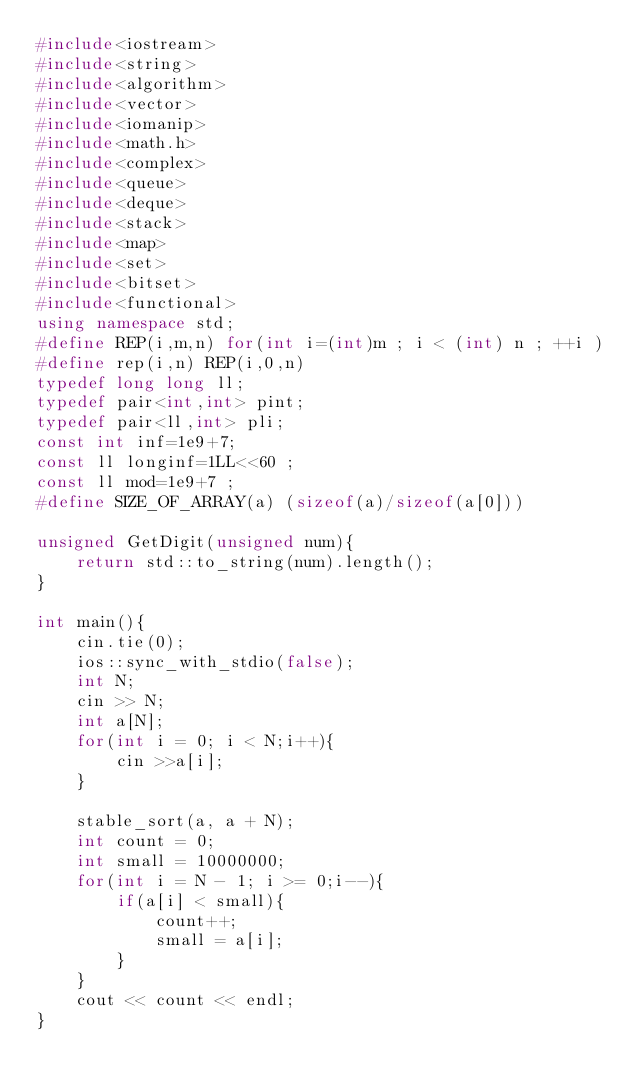Convert code to text. <code><loc_0><loc_0><loc_500><loc_500><_C++_>#include<iostream>
#include<string>
#include<algorithm>
#include<vector>
#include<iomanip>
#include<math.h>
#include<complex>
#include<queue>
#include<deque>
#include<stack>
#include<map>
#include<set>
#include<bitset>
#include<functional>
using namespace std;
#define REP(i,m,n) for(int i=(int)m ; i < (int) n ; ++i )
#define rep(i,n) REP(i,0,n)
typedef long long ll;
typedef pair<int,int> pint;
typedef pair<ll,int> pli;
const int inf=1e9+7;
const ll longinf=1LL<<60 ;
const ll mod=1e9+7 ;
#define SIZE_OF_ARRAY(a) (sizeof(a)/sizeof(a[0]))

unsigned GetDigit(unsigned num){
    return std::to_string(num).length();
}

int main(){
    cin.tie(0);
    ios::sync_with_stdio(false);
    int N;
    cin >> N;
    int a[N];
    for(int i = 0; i < N;i++){
        cin >>a[i];
    }

    stable_sort(a, a + N);
    int count = 0;
    int small = 10000000;
    for(int i = N - 1; i >= 0;i--){
        if(a[i] < small){
            count++;
            small = a[i];
        }
    }
    cout << count << endl;
}


</code> 